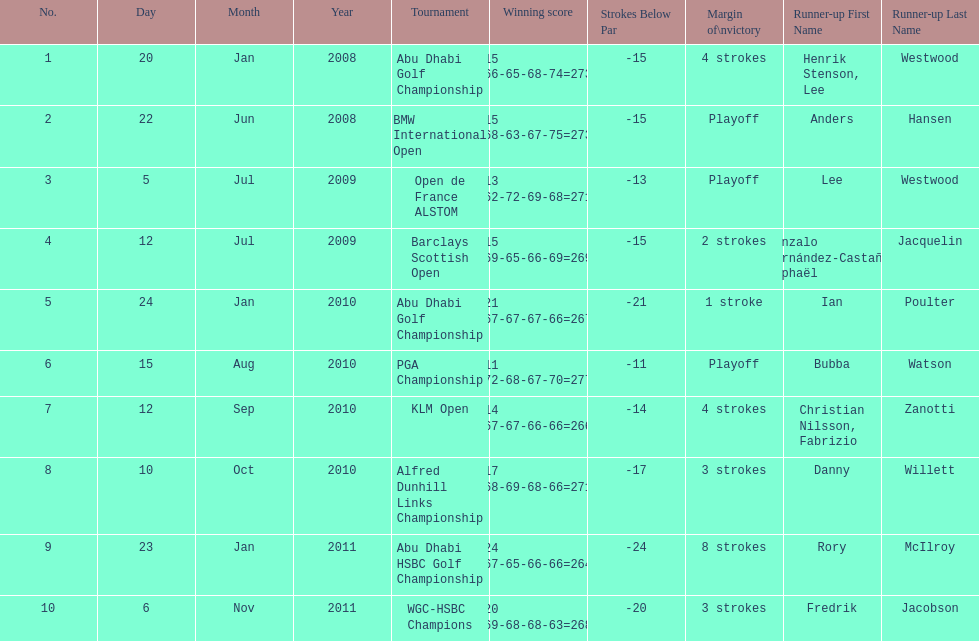What were all the different tournaments played by martin kaymer Abu Dhabi Golf Championship, BMW International Open, Open de France ALSTOM, Barclays Scottish Open, Abu Dhabi Golf Championship, PGA Championship, KLM Open, Alfred Dunhill Links Championship, Abu Dhabi HSBC Golf Championship, WGC-HSBC Champions. Who was the runner-up for the pga championship? Bubba Watson. Can you give me this table as a dict? {'header': ['No.', 'Day', 'Month', 'Year', 'Tournament', 'Winning score', 'Strokes Below Par', 'Margin of\\nvictory', 'Runner-up First Name', 'Runner-up Last Name'], 'rows': [['1', '20', 'Jan', '2008', 'Abu Dhabi Golf Championship', '−15 (66-65-68-74=273)', '-15', '4 strokes', 'Henrik Stenson, Lee', 'Westwood'], ['2', '22', 'Jun', '2008', 'BMW International Open', '−15 (68-63-67-75=273)', '-15', 'Playoff', 'Anders', 'Hansen'], ['3', '5', 'Jul', '2009', 'Open de France ALSTOM', '−13 (62-72-69-68=271)', '-13', 'Playoff', 'Lee', 'Westwood'], ['4', '12', 'Jul', '2009', 'Barclays Scottish Open', '−15 (69-65-66-69=269)', '-15', '2 strokes', 'Gonzalo Fernández-Castaño, Raphaël', 'Jacquelin'], ['5', '24', 'Jan', '2010', 'Abu Dhabi Golf Championship', '−21 (67-67-67-66=267)', '-21', '1 stroke', 'Ian', 'Poulter'], ['6', '15', 'Aug', '2010', 'PGA Championship', '−11 (72-68-67-70=277)', '-11', 'Playoff', 'Bubba', 'Watson'], ['7', '12', 'Sep', '2010', 'KLM Open', '−14 (67-67-66-66=266)', '-14', '4 strokes', 'Christian Nilsson, Fabrizio', 'Zanotti'], ['8', '10', 'Oct', '2010', 'Alfred Dunhill Links Championship', '−17 (68-69-68-66=271)', '-17', '3 strokes', 'Danny', 'Willett'], ['9', '23', 'Jan', '2011', 'Abu Dhabi HSBC Golf Championship', '−24 (67-65-66-66=264)', '-24', '8 strokes', 'Rory', 'McIlroy'], ['10', '6', 'Nov', '2011', 'WGC-HSBC Champions', '−20 (69-68-68-63=268)', '-20', '3 strokes', 'Fredrik', 'Jacobson']]} 